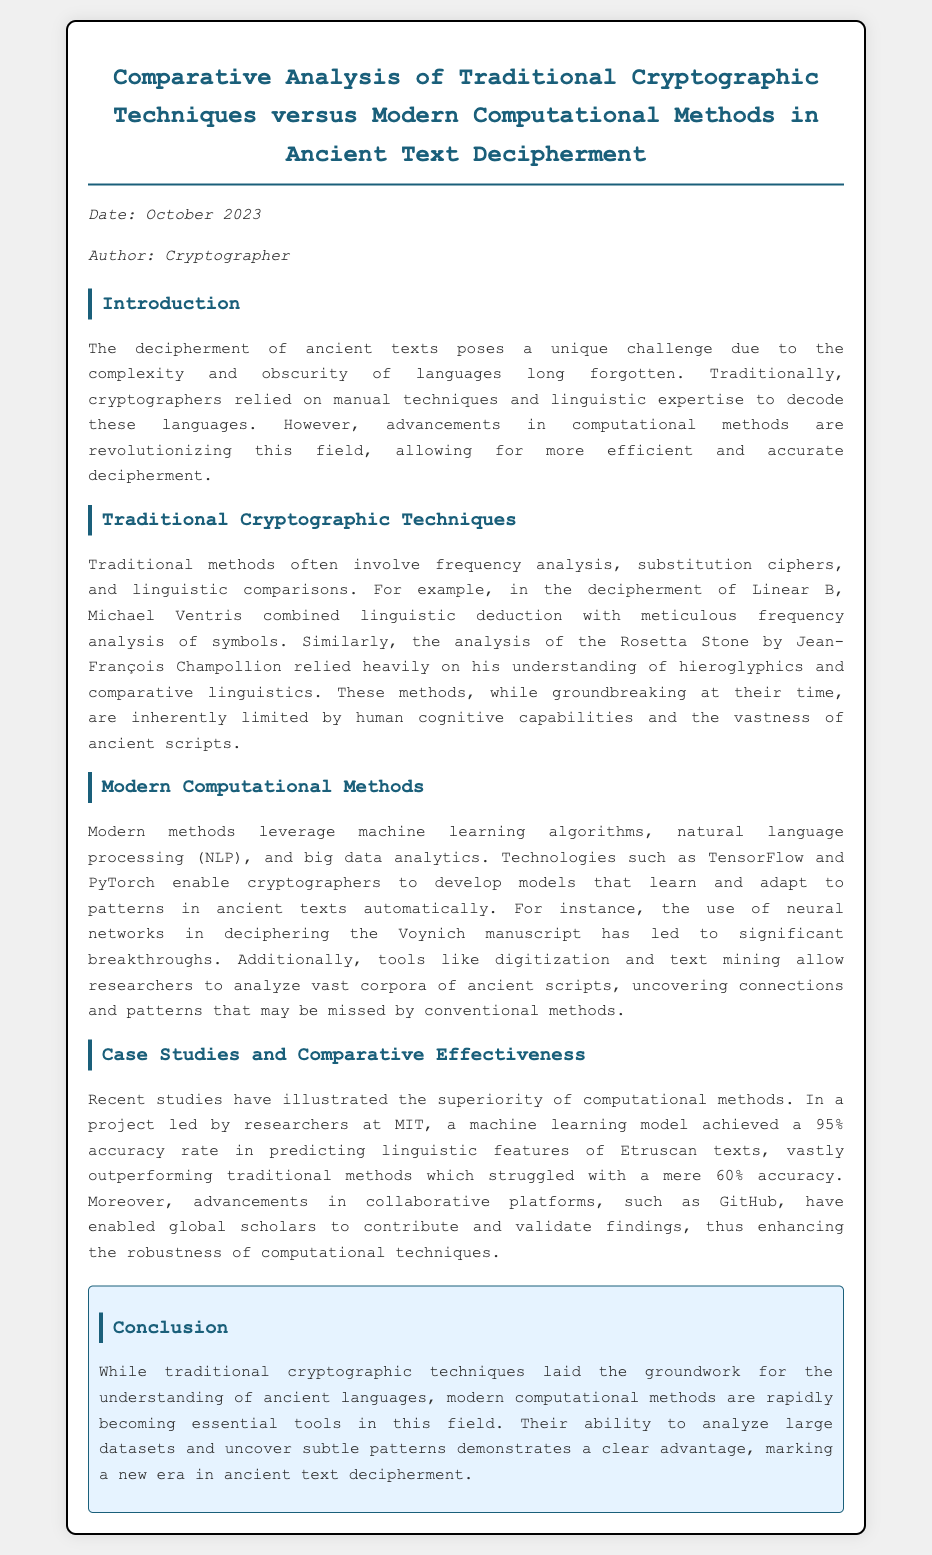What is the title of the memo? The title of the memo is a key piece of information to identify the content of the document.
Answer: Comparative Analysis of Traditional Cryptographic Techniques versus Modern Computational Methods in Ancient Text Decipherment Who is the author of the memo? The author is specified in the metadata section of the document.
Answer: Cryptographer What date was the memo written? The date is mentioned in the metadata and provides context for the document's relevance.
Answer: October 2023 What technique did Michael Ventris use for deciphering Linear B? This technique is specifically mentioned in the context of traditional cryptographic methods.
Answer: Frequency analysis What accuracy rate did the machine learning model achieve for Etruscan texts? The accuracy rate provides a quantifiable measure of the effectiveness of modern methods compared to traditional ones.
Answer: 95% Which ancient manuscript is mentioned as benefiting from neural network analysis? This manuscript showcases the application of modern computational methods within the document.
Answer: Voynich manuscript What are two examples of modern computational methods mentioned? These examples demonstrate the advancements in techniques used for decipherment.
Answer: Machine learning algorithms, natural language processing What was the accuracy of traditional methods for Etruscan texts according to the document? The comparison highlights the limitations of traditional methods in deciphering ancient languages.
Answer: 60% What does the conclusion suggest about the future of ancient text decipherment? Understanding the implications helps assess the transition towards more advanced methods in the field.
Answer: Modern computational methods are rapidly becoming essential tools 